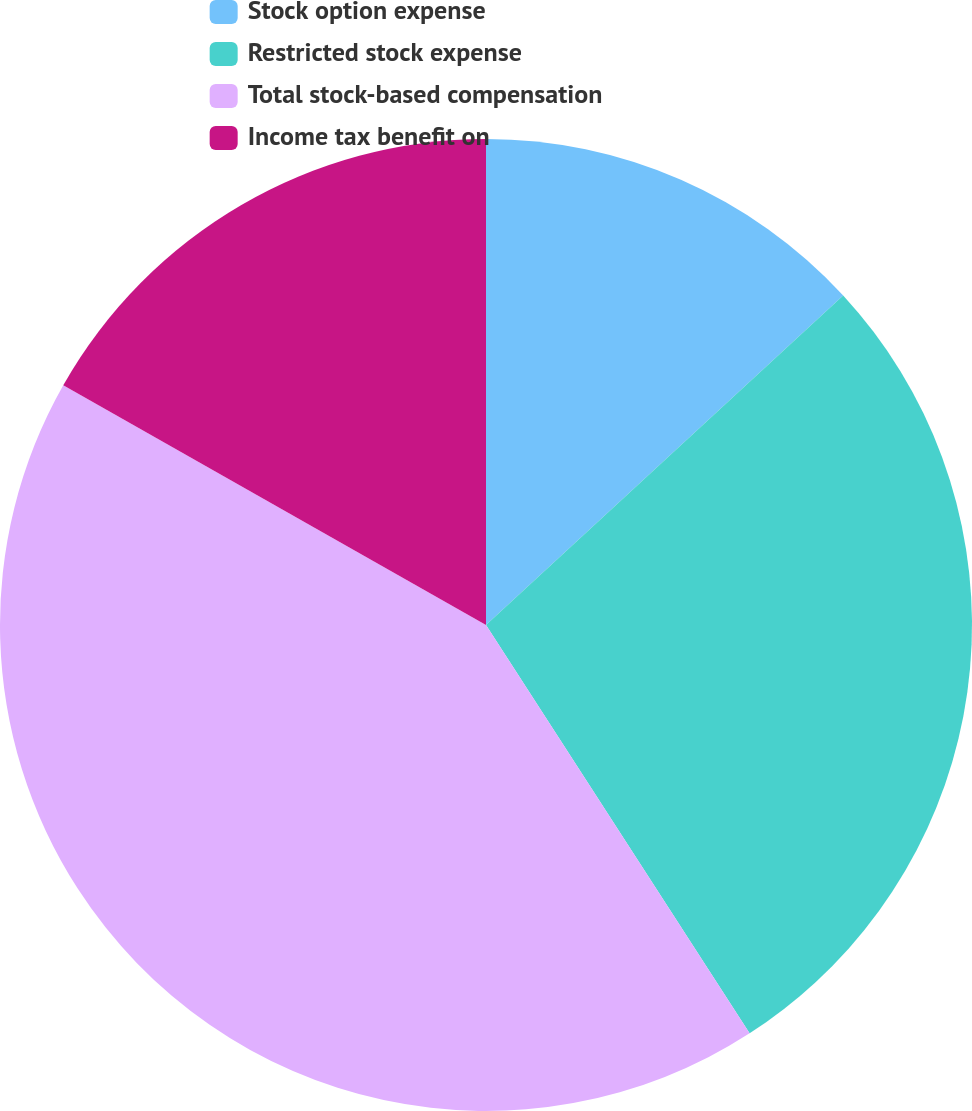Convert chart. <chart><loc_0><loc_0><loc_500><loc_500><pie_chart><fcel>Stock option expense<fcel>Restricted stock expense<fcel>Total stock-based compensation<fcel>Income tax benefit on<nl><fcel>13.14%<fcel>27.74%<fcel>42.34%<fcel>16.79%<nl></chart> 